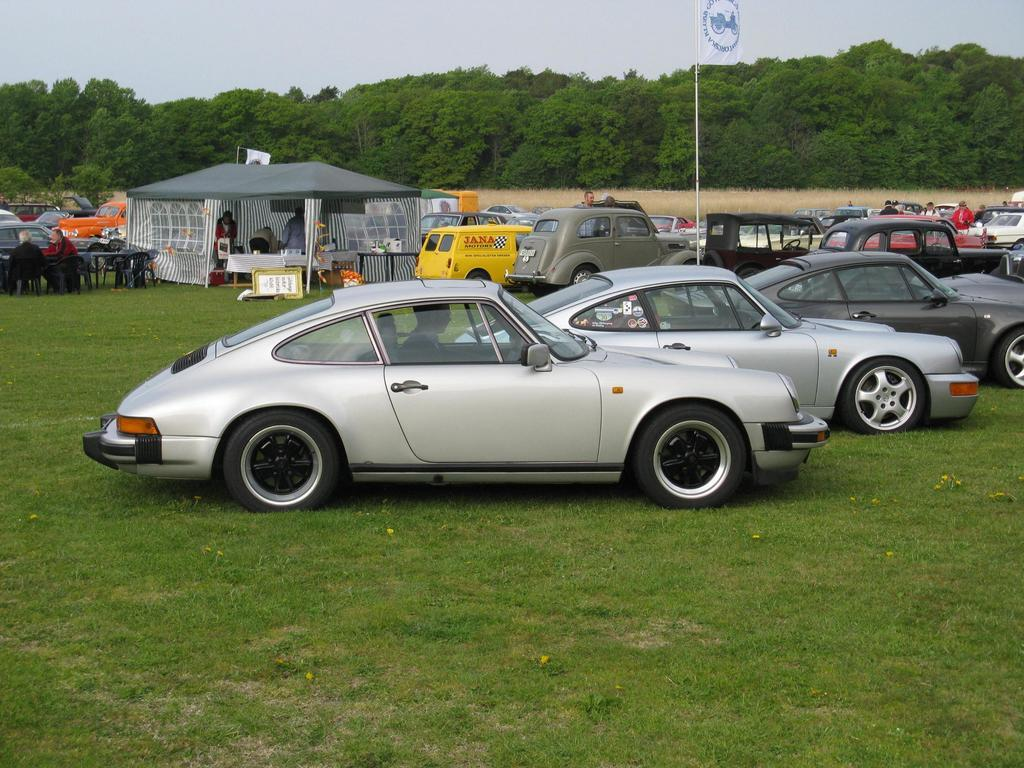What is the main subject of the image? The main subject of the image is cars in a field. Are there any structures or objects in the image besides the cars? Yes, there is a tent, a table, and chairs in the image. Where is the tent located in relation to the cars? The tent is near the cars in the field. What can be seen in the background of the image? There are trees and the sky visible in the background of the image. How many feet are visible on the ladybug in the image? There is no ladybug present in the image, so it is not possible to determine the number of feet on it. 